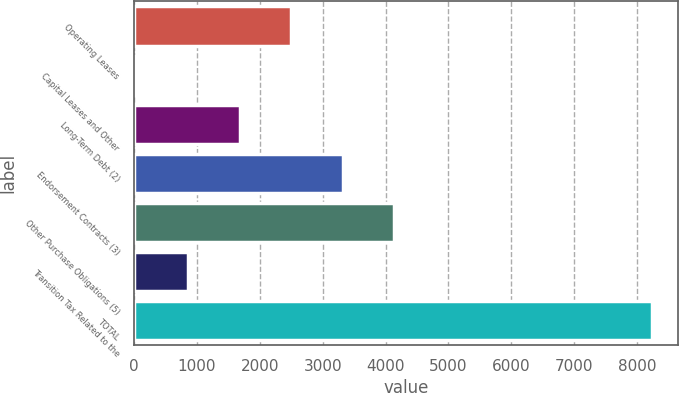<chart> <loc_0><loc_0><loc_500><loc_500><bar_chart><fcel>Operating Leases<fcel>Capital Leases and Other<fcel>Long-Term Debt (2)<fcel>Endorsement Contracts (3)<fcel>Other Purchase Obligations (5)<fcel>Transition Tax Related to the<fcel>TOTAL<nl><fcel>2501.6<fcel>44<fcel>1682.4<fcel>3320.8<fcel>4140<fcel>863.2<fcel>8236<nl></chart> 